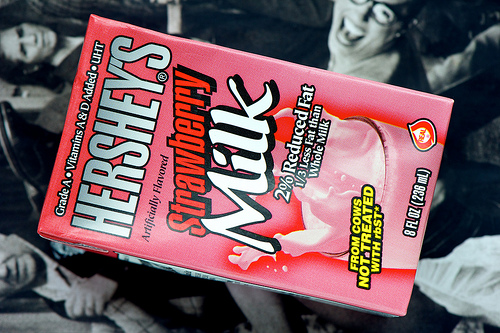<image>
Can you confirm if the milk is in the woman? No. The milk is not contained within the woman. These objects have a different spatial relationship. 